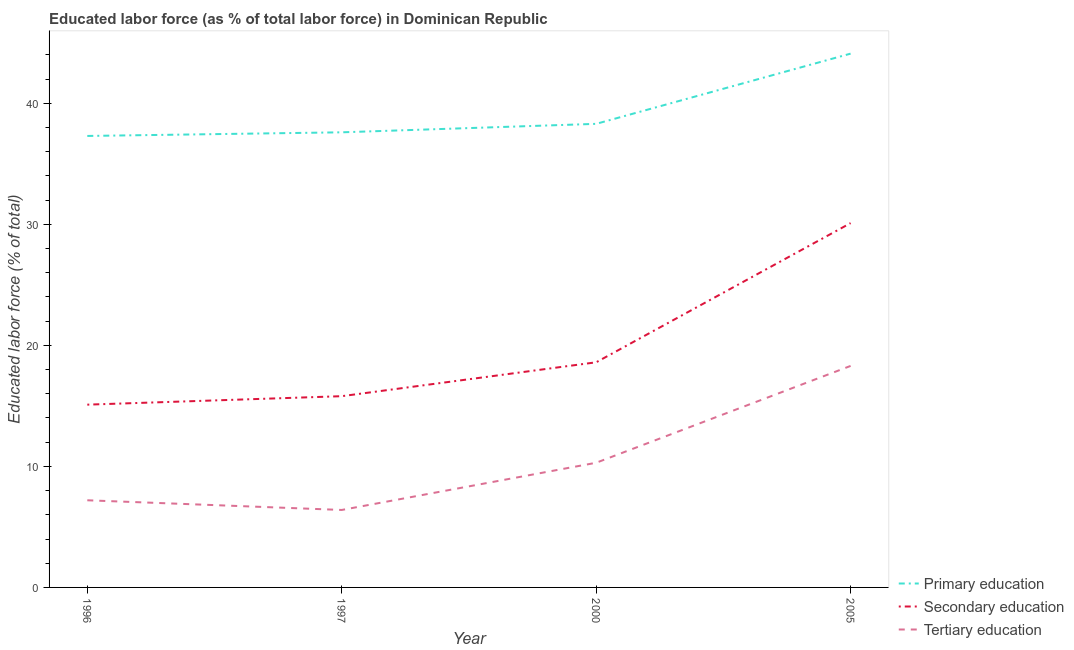Does the line corresponding to percentage of labor force who received primary education intersect with the line corresponding to percentage of labor force who received tertiary education?
Your answer should be very brief. No. What is the percentage of labor force who received secondary education in 2005?
Ensure brevity in your answer.  30.1. Across all years, what is the maximum percentage of labor force who received secondary education?
Provide a short and direct response. 30.1. Across all years, what is the minimum percentage of labor force who received secondary education?
Offer a very short reply. 15.1. What is the total percentage of labor force who received tertiary education in the graph?
Ensure brevity in your answer.  42.2. What is the difference between the percentage of labor force who received secondary education in 1996 and that in 2000?
Offer a very short reply. -3.5. What is the difference between the percentage of labor force who received tertiary education in 2005 and the percentage of labor force who received primary education in 1996?
Your answer should be compact. -19. What is the average percentage of labor force who received secondary education per year?
Keep it short and to the point. 19.9. In the year 1996, what is the difference between the percentage of labor force who received secondary education and percentage of labor force who received tertiary education?
Provide a short and direct response. 7.9. In how many years, is the percentage of labor force who received primary education greater than 16 %?
Your answer should be very brief. 4. What is the ratio of the percentage of labor force who received secondary education in 1997 to that in 2000?
Offer a terse response. 0.85. Is the difference between the percentage of labor force who received secondary education in 1997 and 2000 greater than the difference between the percentage of labor force who received tertiary education in 1997 and 2000?
Make the answer very short. Yes. What is the difference between the highest and the second highest percentage of labor force who received secondary education?
Your response must be concise. 11.5. What is the difference between the highest and the lowest percentage of labor force who received tertiary education?
Offer a terse response. 11.9. In how many years, is the percentage of labor force who received primary education greater than the average percentage of labor force who received primary education taken over all years?
Your response must be concise. 1. Is it the case that in every year, the sum of the percentage of labor force who received primary education and percentage of labor force who received secondary education is greater than the percentage of labor force who received tertiary education?
Provide a succinct answer. Yes. Does the percentage of labor force who received tertiary education monotonically increase over the years?
Your answer should be very brief. No. How many lines are there?
Give a very brief answer. 3. How many years are there in the graph?
Provide a short and direct response. 4. What is the difference between two consecutive major ticks on the Y-axis?
Offer a very short reply. 10. Does the graph contain any zero values?
Offer a terse response. No. How many legend labels are there?
Your answer should be very brief. 3. What is the title of the graph?
Make the answer very short. Educated labor force (as % of total labor force) in Dominican Republic. What is the label or title of the X-axis?
Provide a succinct answer. Year. What is the label or title of the Y-axis?
Make the answer very short. Educated labor force (% of total). What is the Educated labor force (% of total) in Primary education in 1996?
Your answer should be compact. 37.3. What is the Educated labor force (% of total) of Secondary education in 1996?
Offer a terse response. 15.1. What is the Educated labor force (% of total) of Tertiary education in 1996?
Your answer should be compact. 7.2. What is the Educated labor force (% of total) of Primary education in 1997?
Make the answer very short. 37.6. What is the Educated labor force (% of total) in Secondary education in 1997?
Your response must be concise. 15.8. What is the Educated labor force (% of total) of Tertiary education in 1997?
Your answer should be very brief. 6.4. What is the Educated labor force (% of total) in Primary education in 2000?
Provide a short and direct response. 38.3. What is the Educated labor force (% of total) of Secondary education in 2000?
Give a very brief answer. 18.6. What is the Educated labor force (% of total) in Tertiary education in 2000?
Your answer should be very brief. 10.3. What is the Educated labor force (% of total) in Primary education in 2005?
Give a very brief answer. 44.1. What is the Educated labor force (% of total) in Secondary education in 2005?
Provide a succinct answer. 30.1. What is the Educated labor force (% of total) of Tertiary education in 2005?
Ensure brevity in your answer.  18.3. Across all years, what is the maximum Educated labor force (% of total) of Primary education?
Your response must be concise. 44.1. Across all years, what is the maximum Educated labor force (% of total) in Secondary education?
Give a very brief answer. 30.1. Across all years, what is the maximum Educated labor force (% of total) of Tertiary education?
Give a very brief answer. 18.3. Across all years, what is the minimum Educated labor force (% of total) of Primary education?
Offer a very short reply. 37.3. Across all years, what is the minimum Educated labor force (% of total) in Secondary education?
Keep it short and to the point. 15.1. Across all years, what is the minimum Educated labor force (% of total) of Tertiary education?
Provide a succinct answer. 6.4. What is the total Educated labor force (% of total) in Primary education in the graph?
Provide a succinct answer. 157.3. What is the total Educated labor force (% of total) in Secondary education in the graph?
Your answer should be compact. 79.6. What is the total Educated labor force (% of total) of Tertiary education in the graph?
Your answer should be compact. 42.2. What is the difference between the Educated labor force (% of total) of Secondary education in 1996 and that in 1997?
Your answer should be very brief. -0.7. What is the difference between the Educated labor force (% of total) of Primary education in 1997 and that in 2000?
Your response must be concise. -0.7. What is the difference between the Educated labor force (% of total) of Tertiary education in 1997 and that in 2000?
Offer a very short reply. -3.9. What is the difference between the Educated labor force (% of total) of Primary education in 1997 and that in 2005?
Offer a terse response. -6.5. What is the difference between the Educated labor force (% of total) of Secondary education in 1997 and that in 2005?
Give a very brief answer. -14.3. What is the difference between the Educated labor force (% of total) in Tertiary education in 2000 and that in 2005?
Keep it short and to the point. -8. What is the difference between the Educated labor force (% of total) of Primary education in 1996 and the Educated labor force (% of total) of Tertiary education in 1997?
Your answer should be very brief. 30.9. What is the difference between the Educated labor force (% of total) in Primary education in 1996 and the Educated labor force (% of total) in Secondary education in 2000?
Ensure brevity in your answer.  18.7. What is the difference between the Educated labor force (% of total) in Secondary education in 1996 and the Educated labor force (% of total) in Tertiary education in 2000?
Your answer should be very brief. 4.8. What is the difference between the Educated labor force (% of total) of Primary education in 1996 and the Educated labor force (% of total) of Secondary education in 2005?
Provide a succinct answer. 7.2. What is the difference between the Educated labor force (% of total) in Primary education in 1997 and the Educated labor force (% of total) in Secondary education in 2000?
Offer a very short reply. 19. What is the difference between the Educated labor force (% of total) in Primary education in 1997 and the Educated labor force (% of total) in Tertiary education in 2000?
Offer a terse response. 27.3. What is the difference between the Educated labor force (% of total) of Primary education in 1997 and the Educated labor force (% of total) of Secondary education in 2005?
Your response must be concise. 7.5. What is the difference between the Educated labor force (% of total) in Primary education in 1997 and the Educated labor force (% of total) in Tertiary education in 2005?
Provide a succinct answer. 19.3. What is the difference between the Educated labor force (% of total) in Secondary education in 1997 and the Educated labor force (% of total) in Tertiary education in 2005?
Give a very brief answer. -2.5. What is the average Educated labor force (% of total) in Primary education per year?
Give a very brief answer. 39.33. What is the average Educated labor force (% of total) of Secondary education per year?
Provide a short and direct response. 19.9. What is the average Educated labor force (% of total) in Tertiary education per year?
Your answer should be very brief. 10.55. In the year 1996, what is the difference between the Educated labor force (% of total) in Primary education and Educated labor force (% of total) in Secondary education?
Provide a succinct answer. 22.2. In the year 1996, what is the difference between the Educated labor force (% of total) of Primary education and Educated labor force (% of total) of Tertiary education?
Your answer should be very brief. 30.1. In the year 1996, what is the difference between the Educated labor force (% of total) of Secondary education and Educated labor force (% of total) of Tertiary education?
Ensure brevity in your answer.  7.9. In the year 1997, what is the difference between the Educated labor force (% of total) of Primary education and Educated labor force (% of total) of Secondary education?
Provide a succinct answer. 21.8. In the year 1997, what is the difference between the Educated labor force (% of total) of Primary education and Educated labor force (% of total) of Tertiary education?
Provide a succinct answer. 31.2. In the year 2000, what is the difference between the Educated labor force (% of total) in Primary education and Educated labor force (% of total) in Secondary education?
Ensure brevity in your answer.  19.7. In the year 2005, what is the difference between the Educated labor force (% of total) of Primary education and Educated labor force (% of total) of Tertiary education?
Provide a short and direct response. 25.8. In the year 2005, what is the difference between the Educated labor force (% of total) in Secondary education and Educated labor force (% of total) in Tertiary education?
Your answer should be very brief. 11.8. What is the ratio of the Educated labor force (% of total) in Primary education in 1996 to that in 1997?
Provide a short and direct response. 0.99. What is the ratio of the Educated labor force (% of total) in Secondary education in 1996 to that in 1997?
Offer a very short reply. 0.96. What is the ratio of the Educated labor force (% of total) in Tertiary education in 1996 to that in 1997?
Offer a terse response. 1.12. What is the ratio of the Educated labor force (% of total) of Primary education in 1996 to that in 2000?
Offer a very short reply. 0.97. What is the ratio of the Educated labor force (% of total) of Secondary education in 1996 to that in 2000?
Provide a short and direct response. 0.81. What is the ratio of the Educated labor force (% of total) of Tertiary education in 1996 to that in 2000?
Provide a succinct answer. 0.7. What is the ratio of the Educated labor force (% of total) in Primary education in 1996 to that in 2005?
Keep it short and to the point. 0.85. What is the ratio of the Educated labor force (% of total) of Secondary education in 1996 to that in 2005?
Provide a succinct answer. 0.5. What is the ratio of the Educated labor force (% of total) of Tertiary education in 1996 to that in 2005?
Keep it short and to the point. 0.39. What is the ratio of the Educated labor force (% of total) of Primary education in 1997 to that in 2000?
Your response must be concise. 0.98. What is the ratio of the Educated labor force (% of total) in Secondary education in 1997 to that in 2000?
Make the answer very short. 0.85. What is the ratio of the Educated labor force (% of total) in Tertiary education in 1997 to that in 2000?
Offer a terse response. 0.62. What is the ratio of the Educated labor force (% of total) in Primary education in 1997 to that in 2005?
Give a very brief answer. 0.85. What is the ratio of the Educated labor force (% of total) in Secondary education in 1997 to that in 2005?
Give a very brief answer. 0.52. What is the ratio of the Educated labor force (% of total) in Tertiary education in 1997 to that in 2005?
Offer a very short reply. 0.35. What is the ratio of the Educated labor force (% of total) in Primary education in 2000 to that in 2005?
Your response must be concise. 0.87. What is the ratio of the Educated labor force (% of total) of Secondary education in 2000 to that in 2005?
Give a very brief answer. 0.62. What is the ratio of the Educated labor force (% of total) of Tertiary education in 2000 to that in 2005?
Your response must be concise. 0.56. What is the difference between the highest and the lowest Educated labor force (% of total) of Secondary education?
Your response must be concise. 15. What is the difference between the highest and the lowest Educated labor force (% of total) in Tertiary education?
Offer a very short reply. 11.9. 